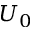Convert formula to latex. <formula><loc_0><loc_0><loc_500><loc_500>U _ { 0 }</formula> 